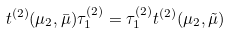Convert formula to latex. <formula><loc_0><loc_0><loc_500><loc_500>t ^ { ( 2 ) } ( \mu _ { 2 } , \bar { \mu } ) \tau ^ { ( 2 ) } _ { 1 } = \tau ^ { ( 2 ) } _ { 1 } t ^ { ( 2 ) } ( \mu _ { 2 } , \tilde { \mu } )</formula> 